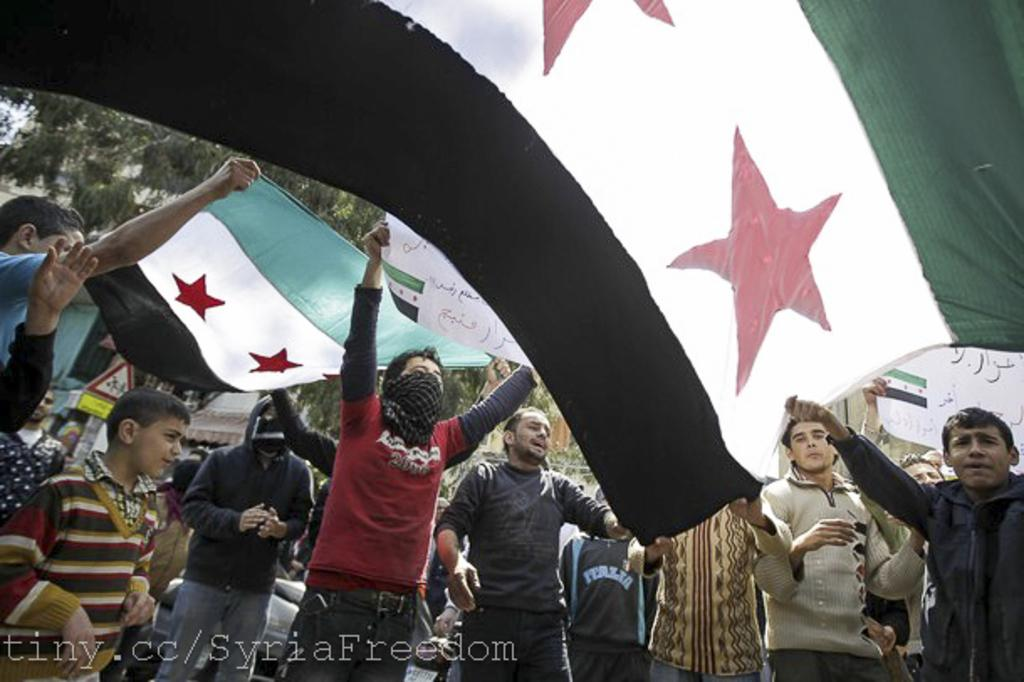What are the persons in the image doing? The persons in the image are holding a flag and a banner. What can be seen in the distance in the image? There are trees and a sign board visible in the distance. What is the person wearing in the red t-shirt doing? The person in the red t-shirt is holding a flag and has a scarf covering their face. How many persons are visible in the image? The number of persons is not specified in the facts, but there are at least two persons holding a flag and a banner. How does the person in the red t-shirt aid in the digestion process in the image? There is no information about digestion in the image, and the person in the red t-shirt is not performing any actions related to digestion. What direction are the persons turning in the image? The facts do not mention any turning or movement by the persons in the image. 